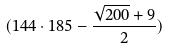<formula> <loc_0><loc_0><loc_500><loc_500>( 1 4 4 \cdot 1 8 5 - \frac { \sqrt { 2 0 0 } + 9 } { 2 } )</formula> 